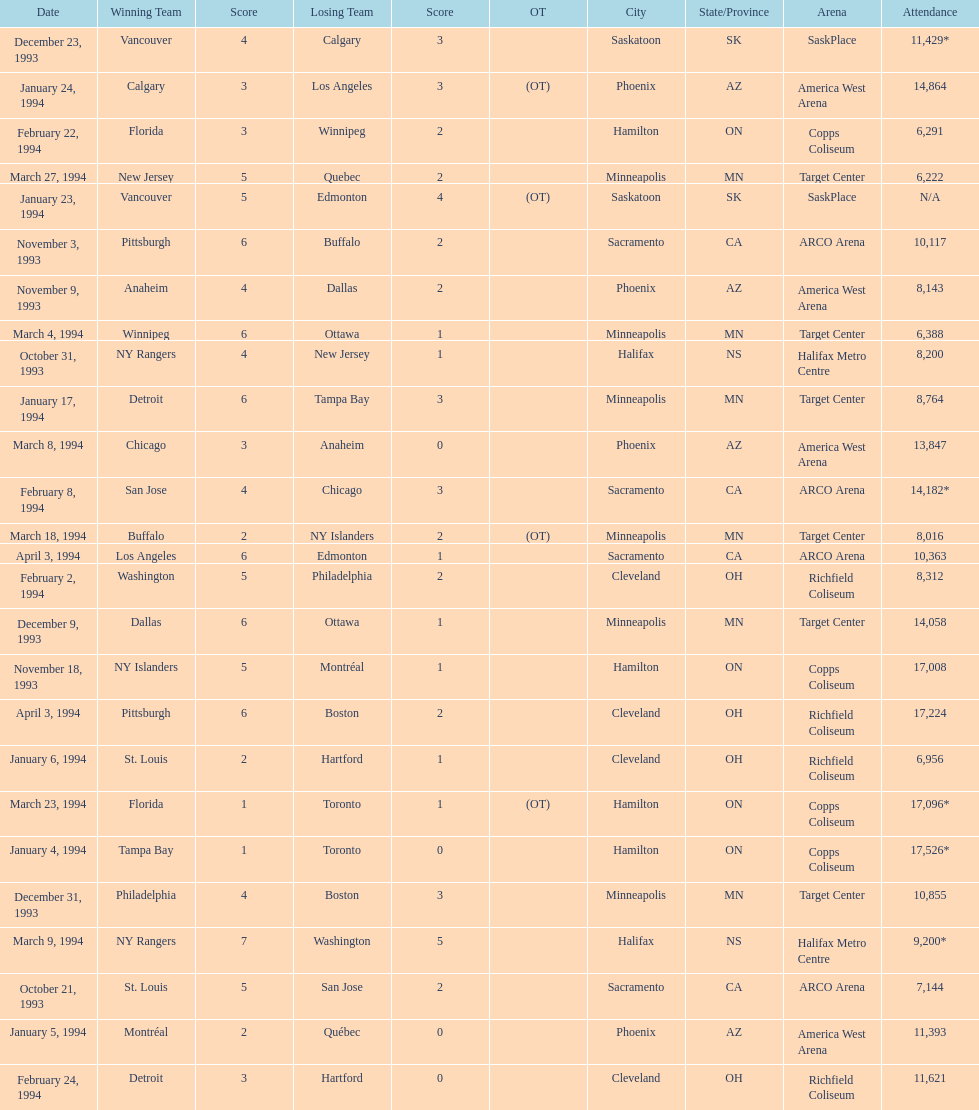What are the attendances of the 1993-94 nhl season? 7,144, 8,200, 10,117, 8,143, 17,008, 14,058, 11,429*, 10,855, 17,526*, 11,393, 6,956, 8,764, N/A, 14,864, 8,312, 14,182*, 6,291, 11,621, 6,388, 13,847, 9,200*, 8,016, 17,096*, 6,222, 17,224, 10,363. Which of these is the highest attendance? 17,526*. Which date did this attendance occur? January 4, 1994. 